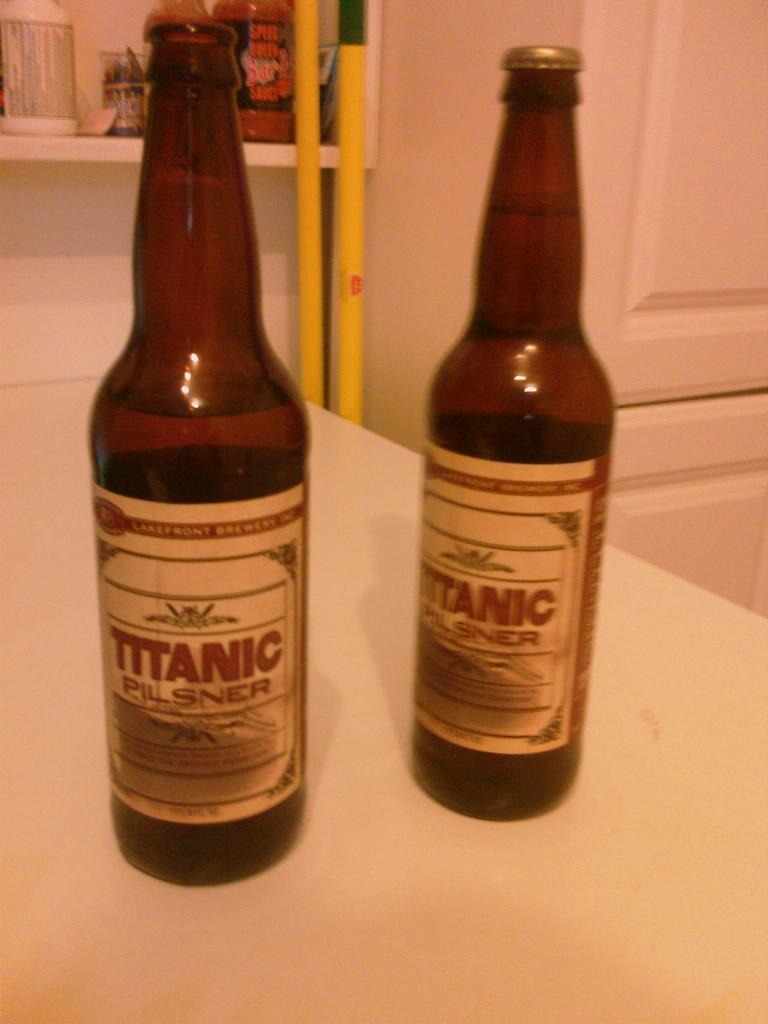Provide a one-sentence caption for the provided image. Two bottles of Titanic brand beer stand upright on a pale table. 